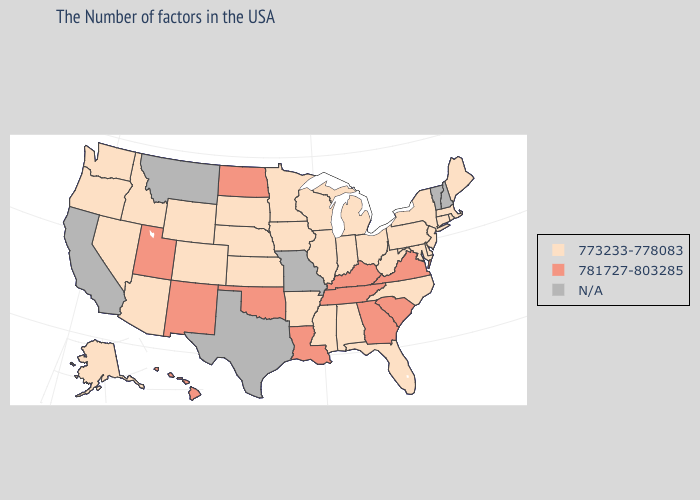What is the value of Wisconsin?
Answer briefly. 773233-778083. What is the highest value in states that border Montana?
Keep it brief. 781727-803285. Does the first symbol in the legend represent the smallest category?
Give a very brief answer. Yes. Does Georgia have the lowest value in the USA?
Keep it brief. No. Does Tennessee have the lowest value in the USA?
Be succinct. No. What is the lowest value in the USA?
Give a very brief answer. 773233-778083. Which states have the lowest value in the Northeast?
Write a very short answer. Maine, Massachusetts, Rhode Island, Connecticut, New York, New Jersey, Pennsylvania. Does Colorado have the highest value in the West?
Quick response, please. No. Which states hav the highest value in the West?
Short answer required. New Mexico, Utah, Hawaii. What is the lowest value in the USA?
Quick response, please. 773233-778083. Name the states that have a value in the range N/A?
Be succinct. New Hampshire, Vermont, Missouri, Texas, Montana, California. Does the first symbol in the legend represent the smallest category?
Be succinct. Yes. What is the value of Texas?
Be succinct. N/A. What is the lowest value in the USA?
Concise answer only. 773233-778083. 